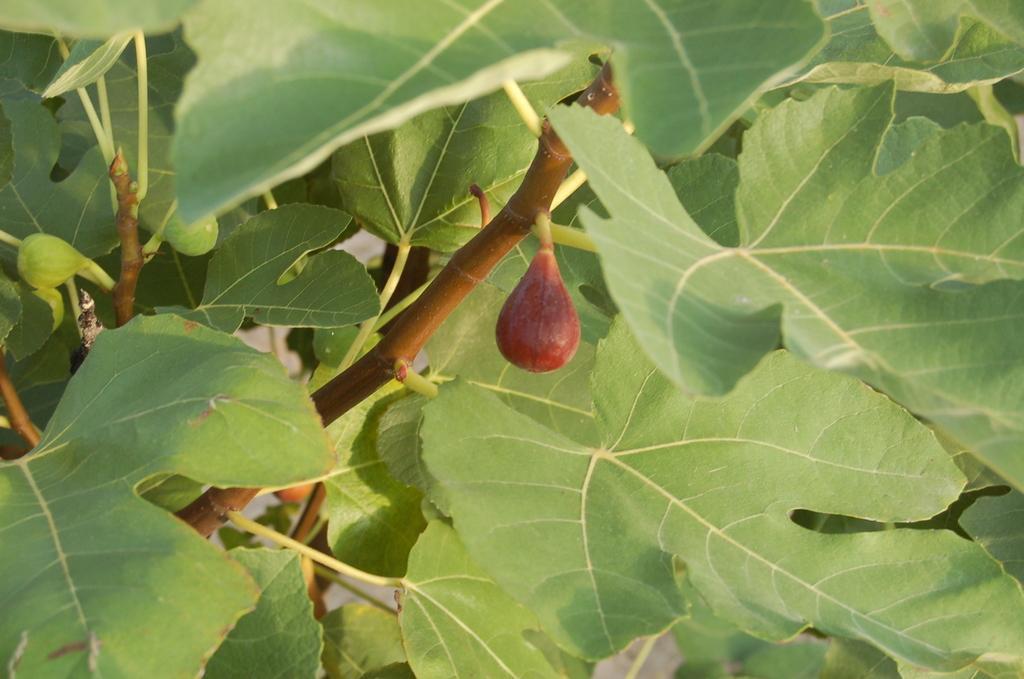Can you describe this image briefly? In this image we can see some fruits and leaves on branches of a tree. 